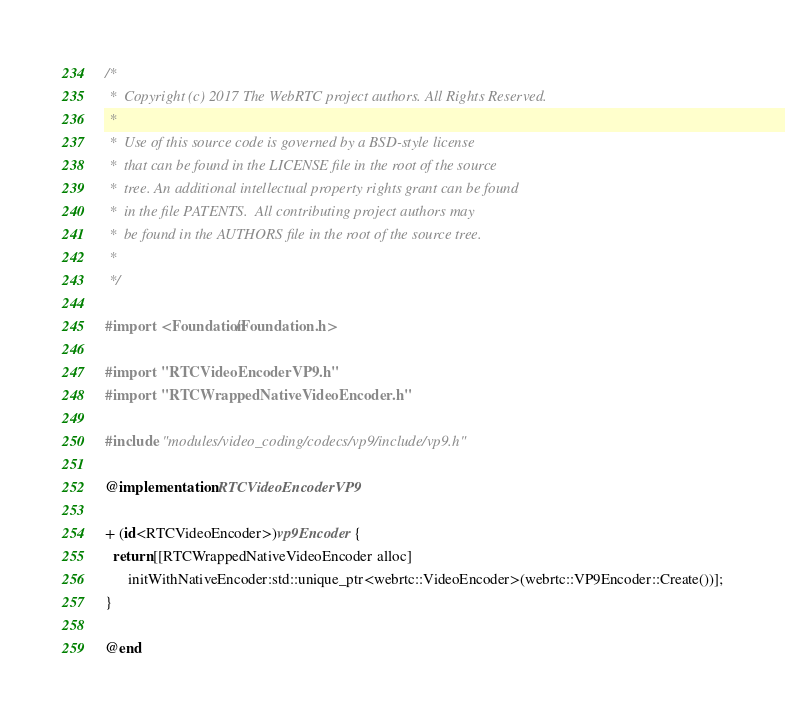Convert code to text. <code><loc_0><loc_0><loc_500><loc_500><_ObjectiveC_>/*
 *  Copyright (c) 2017 The WebRTC project authors. All Rights Reserved.
 *
 *  Use of this source code is governed by a BSD-style license
 *  that can be found in the LICENSE file in the root of the source
 *  tree. An additional intellectual property rights grant can be found
 *  in the file PATENTS.  All contributing project authors may
 *  be found in the AUTHORS file in the root of the source tree.
 *
 */

#import <Foundation/Foundation.h>

#import "RTCVideoEncoderVP9.h"
#import "RTCWrappedNativeVideoEncoder.h"

#include "modules/video_coding/codecs/vp9/include/vp9.h"

@implementation RTCVideoEncoderVP9

+ (id<RTCVideoEncoder>)vp9Encoder {
  return [[RTCWrappedNativeVideoEncoder alloc]
      initWithNativeEncoder:std::unique_ptr<webrtc::VideoEncoder>(webrtc::VP9Encoder::Create())];
}

@end
</code> 